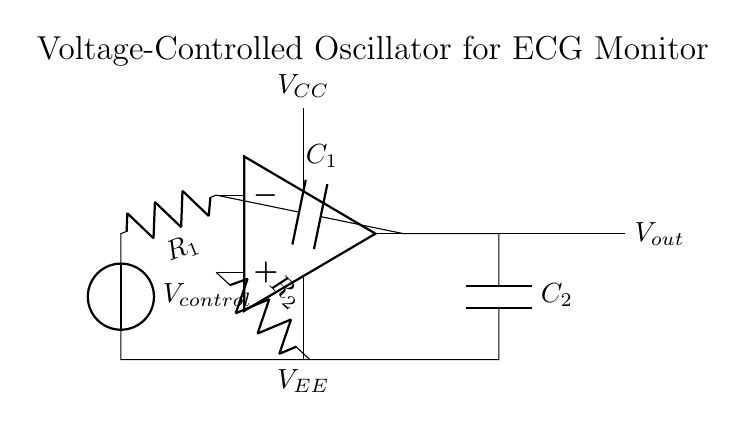What is the main function of the op-amp in this circuit? The op-amp acts as a voltage-controlled oscillator, where it amplifies the input signal and helps generate oscillations controlled by the voltage input.
Answer: voltage-controlled oscillator What type of components are C1 and C2? C1 and C2 are capacitors, indicated by the symbol 'C' in the circuit diagram. They are used for feedback and output filtering in the oscillator.
Answer: capacitors What is the role of resistor R1 in this circuit? R1 provides feedback to the op-amp, adjusting the gain and influencing the oscillation frequency based on the control voltage.
Answer: feedback What is the supply voltage denoted in the circuit? The circuit shows two voltage supplies, labeled V_CC for the positive supply and V_EE for the negative supply.
Answer: V_CC and V_EE How does the control voltage affect the output frequency? The control voltage directly influences the feedback loop's gain, thus altering the oscillation rate produced by the op-amp. Higher control voltage generally results in higher output frequency.
Answer: alters oscillation rate What is the output voltage denoted as in the circuit? The output voltage is denoted as V_out, which is the voltage signal generated by the oscillator circuit at the output terminal.
Answer: V_out What is the purpose of the feedback capacitor C1? C1 is used to create a feedback loop that is essential for the oscillation process, stabilizing the signal and setting the frequency along with R1.
Answer: feedback loop stabilization 